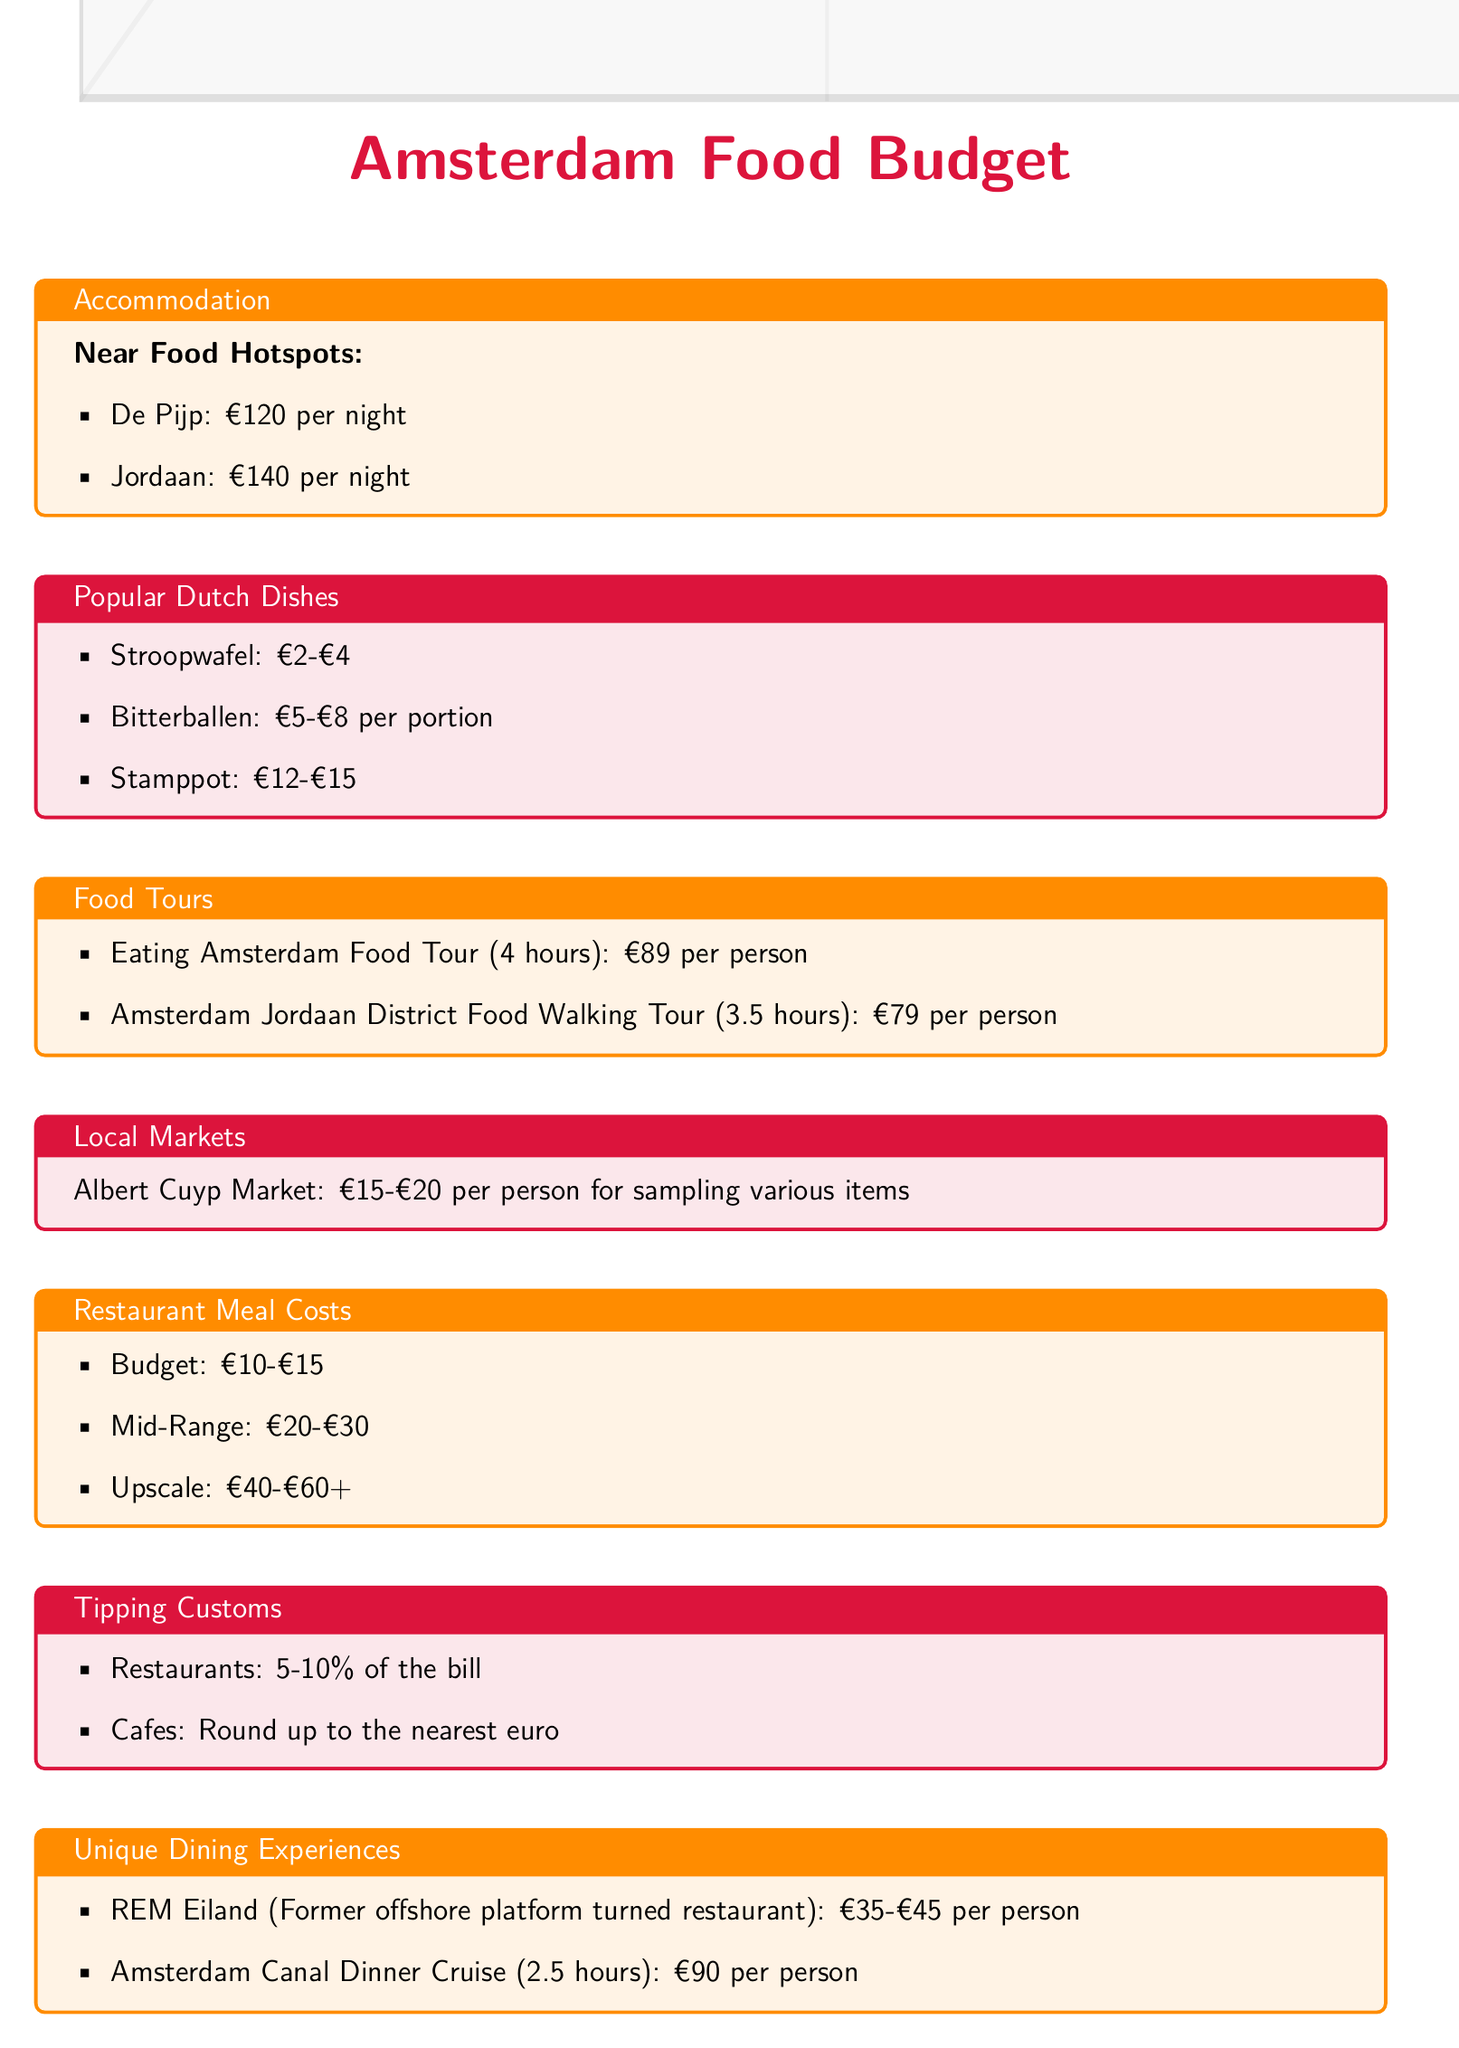What is the price range for Bitterballen? The document lists the price range for Bitterballen as €5-€8 per portion.
Answer: €5-€8 What is the cost of the Eating Amsterdam Food Tour? The document states that the Eating Amsterdam Food Tour costs €89 per person.
Answer: €89 What is the estimated expense for sampling items at Albert Cuyp Market? The document indicates that the estimated expense for sampling items at Albert Cuyp Market is €15-€20 per person.
Answer: €15-€20 How much should you tip at cafes? The document advises rounding up to the nearest euro when tipping at cafes.
Answer: Round up to the nearest euro What is the price range for a budget restaurant meal? The price range for a budget restaurant meal is listed as €10-€15.
Answer: €10-€15 Which neighborhood has accommodation for €120 per night? The document mentions De Pijp has accommodation for €120 per night.
Answer: De Pijp How much does a mid-range restaurant meal cost? A mid-range restaurant meal costs between €20-€30 according to the document.
Answer: €20-€30 What is the price for the Amsterdam Canal Dinner Cruise? The document states that the Amsterdam Canal Dinner Cruise costs €90 per person.
Answer: €90 